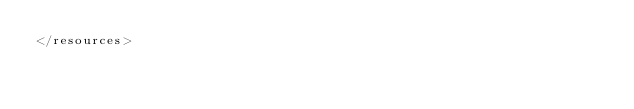Convert code to text. <code><loc_0><loc_0><loc_500><loc_500><_XML_></resources>
</code> 